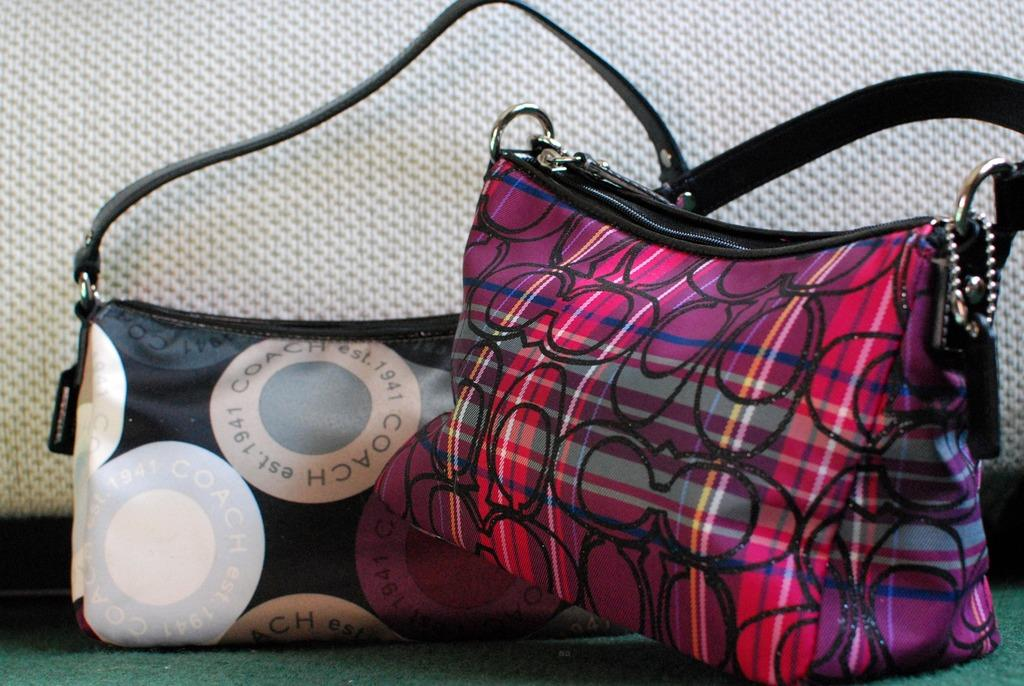How many bags can be seen in the image? There are two bags in the image. What type of clover is growing out of the bags in the image? There is no clover present in the image; it only features two bags. 